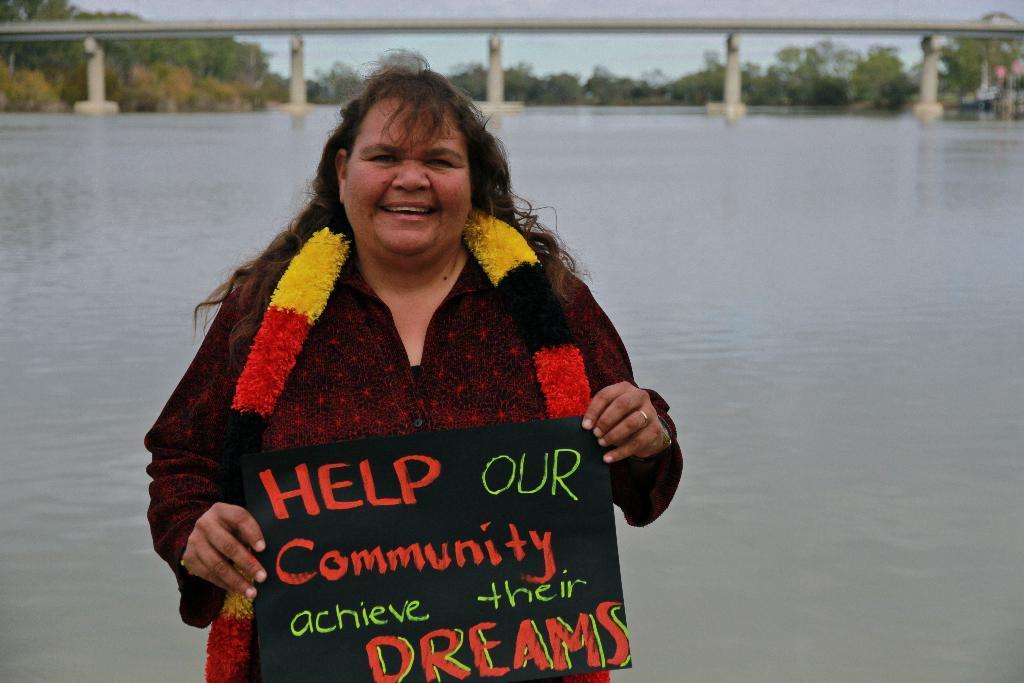Can you describe this image briefly? In this picture we can see a woman is holding a board. On the board, it is written something. Behind the woman there is a lake, bridge, trees and the sky. 